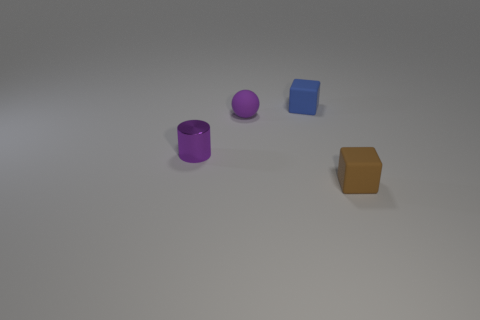If the objects were to represent a family, what roles could they play based on their sizes and colors? In a playful take, the larger purple cylinder could be seen as a protective parent, the spherical purple object as a sibling, and the small blue cube could represent a curious child. The brown block might then be an elder, with its stable, grounded form signifying wisdom and experience. 